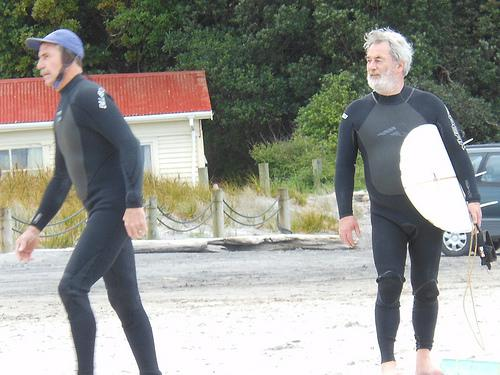Question: who is holding the surfboard?
Choices:
A. The man with the beard.
B. The man in the wetsuit.
C. The woman in the wetsuit.
D. The man with long hair.
Answer with the letter. Answer: A Question: where are they at?
Choices:
A. On a mountain.
B. On a boat.
C. The beach.
D. In the forest.
Answer with the letter. Answer: C Question: what is on the man on the lefts head?
Choices:
A. A visor.
B. A cap.
C. A top-hat.
D. A turban.
Answer with the letter. Answer: B Question: how many men are there?
Choices:
A. Three.
B. Four.
C. Five.
D. Two.
Answer with the letter. Answer: D Question: why are they looking to the left?
Choices:
A. At the water.
B. At the animals.
C. At the mountains.
D. At the group of people.
Answer with the letter. Answer: A Question: what is the man on the right holding?
Choices:
A. A surfboard.
B. A skateboard.
C. A helmet.
D. A beach towel.
Answer with the letter. Answer: A 